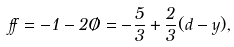<formula> <loc_0><loc_0><loc_500><loc_500>\alpha = - 1 - 2 \chi = - \frac { 5 } { 3 } + \frac { 2 } { 3 } ( d - y ) ,</formula> 